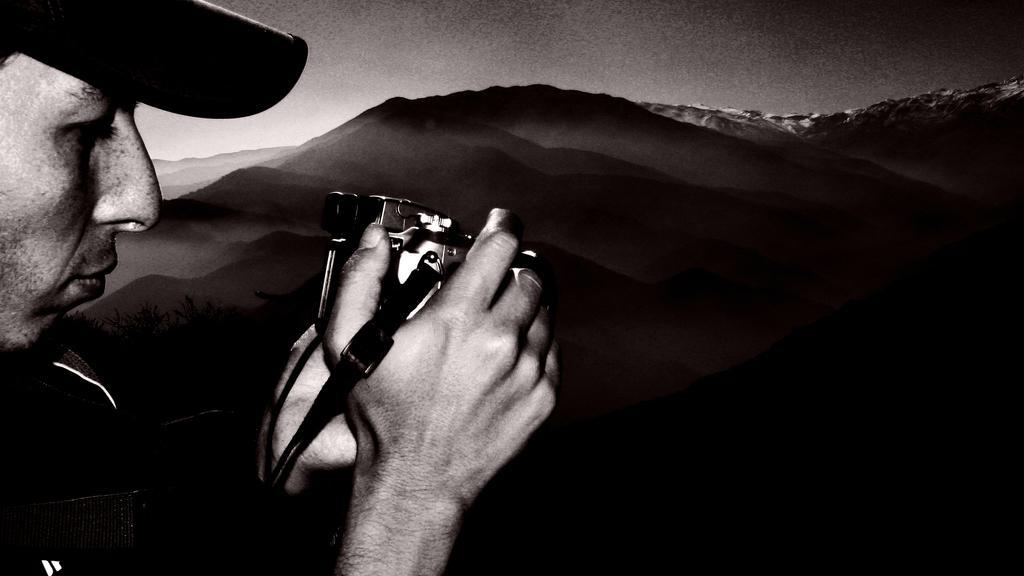Describe this image in one or two sentences. In this image I can see a man and I can see he is holding a camera. I can also see he is wearing a cap and I can see this image is black and white in colour. 